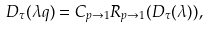Convert formula to latex. <formula><loc_0><loc_0><loc_500><loc_500>D _ { \tau } ( \lambda q ) = C _ { p \rightarrow 1 } R _ { p \rightarrow 1 } ( D _ { \tau } ( \lambda ) ) ,</formula> 